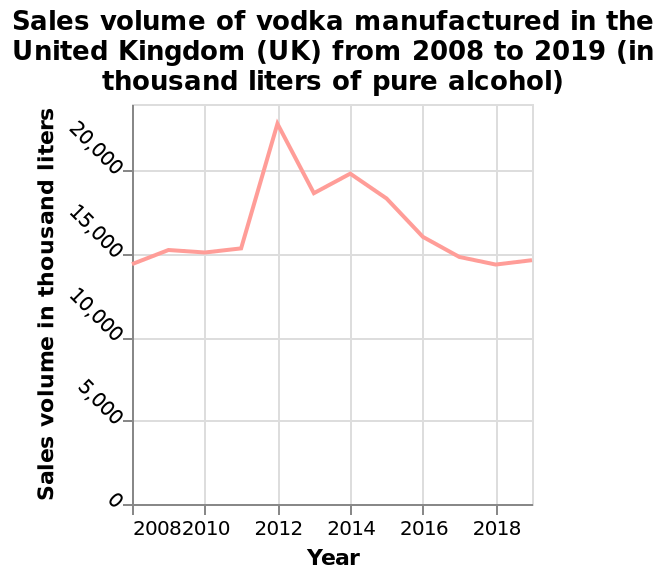<image>
What is plotted along the y-axis of the line plot?  The sales volume in thousand liters of vodka is plotted along the y-axis. What was the sales volume in 2012?  The sales volume in 2012 was almost 24,000 liters. 